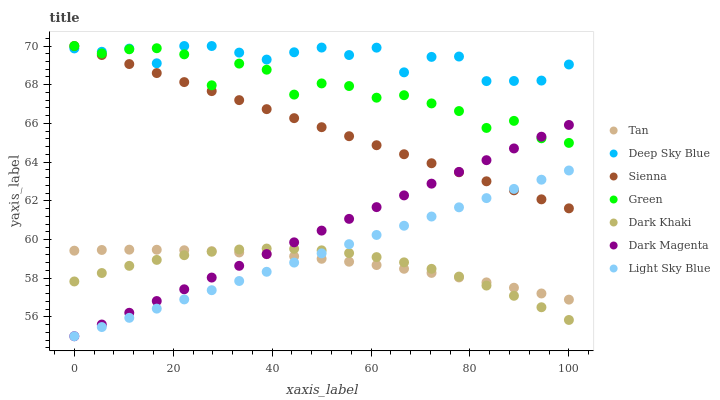Does Dark Khaki have the minimum area under the curve?
Answer yes or no. Yes. Does Deep Sky Blue have the maximum area under the curve?
Answer yes or no. Yes. Does Dark Magenta have the minimum area under the curve?
Answer yes or no. No. Does Dark Magenta have the maximum area under the curve?
Answer yes or no. No. Is Light Sky Blue the smoothest?
Answer yes or no. Yes. Is Green the roughest?
Answer yes or no. Yes. Is Dark Magenta the smoothest?
Answer yes or no. No. Is Dark Magenta the roughest?
Answer yes or no. No. Does Dark Magenta have the lowest value?
Answer yes or no. Yes. Does Sienna have the lowest value?
Answer yes or no. No. Does Deep Sky Blue have the highest value?
Answer yes or no. Yes. Does Dark Magenta have the highest value?
Answer yes or no. No. Is Light Sky Blue less than Green?
Answer yes or no. Yes. Is Sienna greater than Dark Khaki?
Answer yes or no. Yes. Does Green intersect Sienna?
Answer yes or no. Yes. Is Green less than Sienna?
Answer yes or no. No. Is Green greater than Sienna?
Answer yes or no. No. Does Light Sky Blue intersect Green?
Answer yes or no. No. 